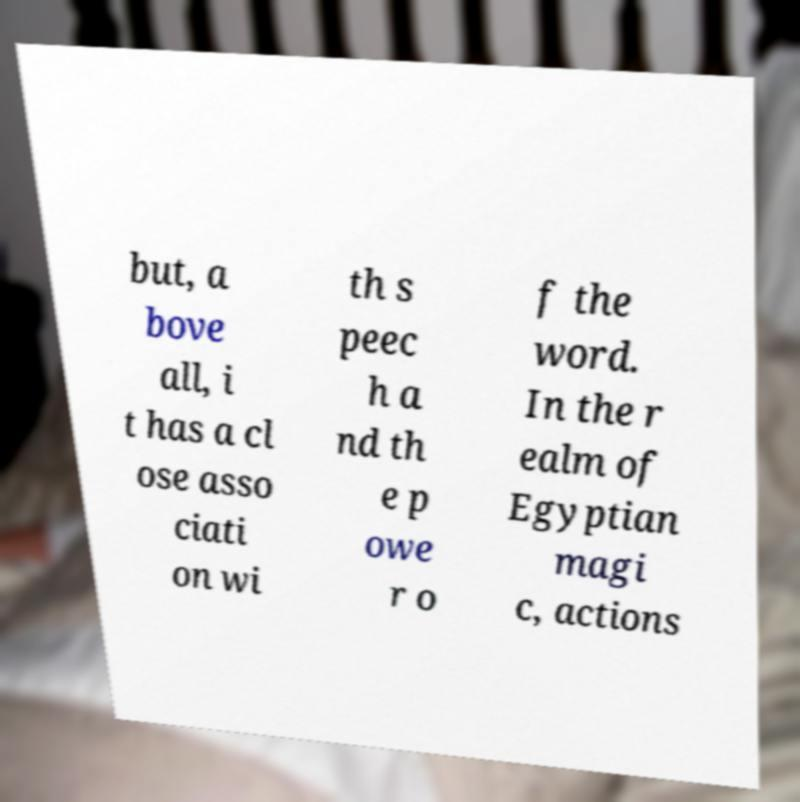Please read and relay the text visible in this image. What does it say? but, a bove all, i t has a cl ose asso ciati on wi th s peec h a nd th e p owe r o f the word. In the r ealm of Egyptian magi c, actions 